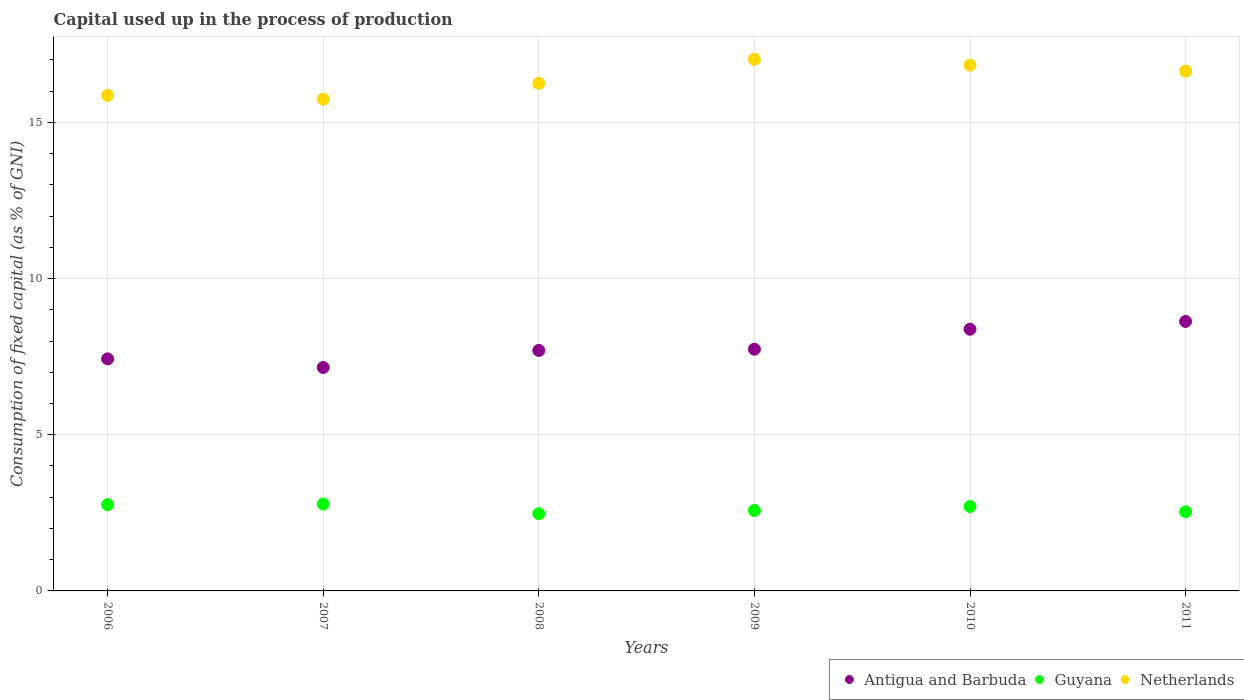What is the capital used up in the process of production in Netherlands in 2007?
Your answer should be compact. 15.75. Across all years, what is the maximum capital used up in the process of production in Netherlands?
Give a very brief answer. 17.02. Across all years, what is the minimum capital used up in the process of production in Guyana?
Your response must be concise. 2.47. What is the total capital used up in the process of production in Antigua and Barbuda in the graph?
Make the answer very short. 47.03. What is the difference between the capital used up in the process of production in Antigua and Barbuda in 2009 and that in 2010?
Provide a short and direct response. -0.64. What is the difference between the capital used up in the process of production in Antigua and Barbuda in 2006 and the capital used up in the process of production in Netherlands in 2007?
Make the answer very short. -8.32. What is the average capital used up in the process of production in Guyana per year?
Provide a short and direct response. 2.64. In the year 2007, what is the difference between the capital used up in the process of production in Netherlands and capital used up in the process of production in Guyana?
Ensure brevity in your answer.  12.96. In how many years, is the capital used up in the process of production in Guyana greater than 12 %?
Your response must be concise. 0. What is the ratio of the capital used up in the process of production in Guyana in 2009 to that in 2011?
Ensure brevity in your answer.  1.02. What is the difference between the highest and the second highest capital used up in the process of production in Antigua and Barbuda?
Keep it short and to the point. 0.25. What is the difference between the highest and the lowest capital used up in the process of production in Guyana?
Provide a short and direct response. 0.31. In how many years, is the capital used up in the process of production in Netherlands greater than the average capital used up in the process of production in Netherlands taken over all years?
Give a very brief answer. 3. Is the sum of the capital used up in the process of production in Netherlands in 2006 and 2010 greater than the maximum capital used up in the process of production in Guyana across all years?
Offer a very short reply. Yes. Is it the case that in every year, the sum of the capital used up in the process of production in Netherlands and capital used up in the process of production in Antigua and Barbuda  is greater than the capital used up in the process of production in Guyana?
Provide a short and direct response. Yes. Is the capital used up in the process of production in Guyana strictly less than the capital used up in the process of production in Antigua and Barbuda over the years?
Offer a very short reply. Yes. What is the difference between two consecutive major ticks on the Y-axis?
Give a very brief answer. 5. Are the values on the major ticks of Y-axis written in scientific E-notation?
Your response must be concise. No. Does the graph contain any zero values?
Your answer should be very brief. No. How many legend labels are there?
Provide a short and direct response. 3. How are the legend labels stacked?
Ensure brevity in your answer.  Horizontal. What is the title of the graph?
Your answer should be very brief. Capital used up in the process of production. Does "Nigeria" appear as one of the legend labels in the graph?
Offer a very short reply. No. What is the label or title of the Y-axis?
Give a very brief answer. Consumption of fixed capital (as % of GNI). What is the Consumption of fixed capital (as % of GNI) in Antigua and Barbuda in 2006?
Your answer should be compact. 7.43. What is the Consumption of fixed capital (as % of GNI) of Guyana in 2006?
Your response must be concise. 2.76. What is the Consumption of fixed capital (as % of GNI) of Netherlands in 2006?
Your response must be concise. 15.87. What is the Consumption of fixed capital (as % of GNI) in Antigua and Barbuda in 2007?
Provide a succinct answer. 7.15. What is the Consumption of fixed capital (as % of GNI) in Guyana in 2007?
Keep it short and to the point. 2.78. What is the Consumption of fixed capital (as % of GNI) in Netherlands in 2007?
Your answer should be compact. 15.75. What is the Consumption of fixed capital (as % of GNI) in Antigua and Barbuda in 2008?
Offer a very short reply. 7.7. What is the Consumption of fixed capital (as % of GNI) of Guyana in 2008?
Your response must be concise. 2.47. What is the Consumption of fixed capital (as % of GNI) of Netherlands in 2008?
Your answer should be very brief. 16.25. What is the Consumption of fixed capital (as % of GNI) in Antigua and Barbuda in 2009?
Give a very brief answer. 7.74. What is the Consumption of fixed capital (as % of GNI) of Guyana in 2009?
Offer a very short reply. 2.58. What is the Consumption of fixed capital (as % of GNI) in Netherlands in 2009?
Your answer should be compact. 17.02. What is the Consumption of fixed capital (as % of GNI) in Antigua and Barbuda in 2010?
Make the answer very short. 8.38. What is the Consumption of fixed capital (as % of GNI) of Guyana in 2010?
Offer a terse response. 2.7. What is the Consumption of fixed capital (as % of GNI) of Netherlands in 2010?
Keep it short and to the point. 16.83. What is the Consumption of fixed capital (as % of GNI) in Antigua and Barbuda in 2011?
Make the answer very short. 8.63. What is the Consumption of fixed capital (as % of GNI) in Guyana in 2011?
Keep it short and to the point. 2.53. What is the Consumption of fixed capital (as % of GNI) in Netherlands in 2011?
Offer a very short reply. 16.64. Across all years, what is the maximum Consumption of fixed capital (as % of GNI) of Antigua and Barbuda?
Ensure brevity in your answer.  8.63. Across all years, what is the maximum Consumption of fixed capital (as % of GNI) in Guyana?
Keep it short and to the point. 2.78. Across all years, what is the maximum Consumption of fixed capital (as % of GNI) in Netherlands?
Keep it short and to the point. 17.02. Across all years, what is the minimum Consumption of fixed capital (as % of GNI) in Antigua and Barbuda?
Make the answer very short. 7.15. Across all years, what is the minimum Consumption of fixed capital (as % of GNI) in Guyana?
Offer a very short reply. 2.47. Across all years, what is the minimum Consumption of fixed capital (as % of GNI) of Netherlands?
Your response must be concise. 15.75. What is the total Consumption of fixed capital (as % of GNI) of Antigua and Barbuda in the graph?
Your answer should be very brief. 47.03. What is the total Consumption of fixed capital (as % of GNI) of Guyana in the graph?
Your answer should be very brief. 15.83. What is the total Consumption of fixed capital (as % of GNI) in Netherlands in the graph?
Provide a succinct answer. 98.36. What is the difference between the Consumption of fixed capital (as % of GNI) of Antigua and Barbuda in 2006 and that in 2007?
Offer a terse response. 0.28. What is the difference between the Consumption of fixed capital (as % of GNI) of Guyana in 2006 and that in 2007?
Your answer should be compact. -0.02. What is the difference between the Consumption of fixed capital (as % of GNI) of Netherlands in 2006 and that in 2007?
Offer a terse response. 0.12. What is the difference between the Consumption of fixed capital (as % of GNI) in Antigua and Barbuda in 2006 and that in 2008?
Ensure brevity in your answer.  -0.27. What is the difference between the Consumption of fixed capital (as % of GNI) in Guyana in 2006 and that in 2008?
Your response must be concise. 0.29. What is the difference between the Consumption of fixed capital (as % of GNI) in Netherlands in 2006 and that in 2008?
Give a very brief answer. -0.39. What is the difference between the Consumption of fixed capital (as % of GNI) in Antigua and Barbuda in 2006 and that in 2009?
Offer a very short reply. -0.31. What is the difference between the Consumption of fixed capital (as % of GNI) of Guyana in 2006 and that in 2009?
Provide a short and direct response. 0.19. What is the difference between the Consumption of fixed capital (as % of GNI) in Netherlands in 2006 and that in 2009?
Your answer should be very brief. -1.15. What is the difference between the Consumption of fixed capital (as % of GNI) in Antigua and Barbuda in 2006 and that in 2010?
Provide a succinct answer. -0.95. What is the difference between the Consumption of fixed capital (as % of GNI) of Guyana in 2006 and that in 2010?
Provide a succinct answer. 0.06. What is the difference between the Consumption of fixed capital (as % of GNI) of Netherlands in 2006 and that in 2010?
Your response must be concise. -0.97. What is the difference between the Consumption of fixed capital (as % of GNI) of Antigua and Barbuda in 2006 and that in 2011?
Your answer should be compact. -1.2. What is the difference between the Consumption of fixed capital (as % of GNI) in Guyana in 2006 and that in 2011?
Your response must be concise. 0.23. What is the difference between the Consumption of fixed capital (as % of GNI) of Netherlands in 2006 and that in 2011?
Your answer should be compact. -0.78. What is the difference between the Consumption of fixed capital (as % of GNI) in Antigua and Barbuda in 2007 and that in 2008?
Your response must be concise. -0.55. What is the difference between the Consumption of fixed capital (as % of GNI) in Guyana in 2007 and that in 2008?
Your answer should be compact. 0.31. What is the difference between the Consumption of fixed capital (as % of GNI) of Netherlands in 2007 and that in 2008?
Your answer should be very brief. -0.51. What is the difference between the Consumption of fixed capital (as % of GNI) of Antigua and Barbuda in 2007 and that in 2009?
Provide a short and direct response. -0.58. What is the difference between the Consumption of fixed capital (as % of GNI) of Guyana in 2007 and that in 2009?
Keep it short and to the point. 0.21. What is the difference between the Consumption of fixed capital (as % of GNI) of Netherlands in 2007 and that in 2009?
Your response must be concise. -1.28. What is the difference between the Consumption of fixed capital (as % of GNI) of Antigua and Barbuda in 2007 and that in 2010?
Offer a terse response. -1.22. What is the difference between the Consumption of fixed capital (as % of GNI) in Guyana in 2007 and that in 2010?
Make the answer very short. 0.08. What is the difference between the Consumption of fixed capital (as % of GNI) of Netherlands in 2007 and that in 2010?
Your answer should be very brief. -1.09. What is the difference between the Consumption of fixed capital (as % of GNI) in Antigua and Barbuda in 2007 and that in 2011?
Your answer should be very brief. -1.47. What is the difference between the Consumption of fixed capital (as % of GNI) in Guyana in 2007 and that in 2011?
Offer a terse response. 0.25. What is the difference between the Consumption of fixed capital (as % of GNI) of Netherlands in 2007 and that in 2011?
Keep it short and to the point. -0.9. What is the difference between the Consumption of fixed capital (as % of GNI) of Antigua and Barbuda in 2008 and that in 2009?
Provide a short and direct response. -0.04. What is the difference between the Consumption of fixed capital (as % of GNI) in Guyana in 2008 and that in 2009?
Give a very brief answer. -0.1. What is the difference between the Consumption of fixed capital (as % of GNI) of Netherlands in 2008 and that in 2009?
Your answer should be very brief. -0.77. What is the difference between the Consumption of fixed capital (as % of GNI) of Antigua and Barbuda in 2008 and that in 2010?
Offer a very short reply. -0.68. What is the difference between the Consumption of fixed capital (as % of GNI) of Guyana in 2008 and that in 2010?
Keep it short and to the point. -0.23. What is the difference between the Consumption of fixed capital (as % of GNI) of Netherlands in 2008 and that in 2010?
Provide a succinct answer. -0.58. What is the difference between the Consumption of fixed capital (as % of GNI) of Antigua and Barbuda in 2008 and that in 2011?
Make the answer very short. -0.93. What is the difference between the Consumption of fixed capital (as % of GNI) in Guyana in 2008 and that in 2011?
Make the answer very short. -0.06. What is the difference between the Consumption of fixed capital (as % of GNI) of Netherlands in 2008 and that in 2011?
Keep it short and to the point. -0.39. What is the difference between the Consumption of fixed capital (as % of GNI) in Antigua and Barbuda in 2009 and that in 2010?
Give a very brief answer. -0.64. What is the difference between the Consumption of fixed capital (as % of GNI) in Guyana in 2009 and that in 2010?
Offer a terse response. -0.13. What is the difference between the Consumption of fixed capital (as % of GNI) in Netherlands in 2009 and that in 2010?
Provide a short and direct response. 0.19. What is the difference between the Consumption of fixed capital (as % of GNI) of Antigua and Barbuda in 2009 and that in 2011?
Your answer should be very brief. -0.89. What is the difference between the Consumption of fixed capital (as % of GNI) of Guyana in 2009 and that in 2011?
Make the answer very short. 0.04. What is the difference between the Consumption of fixed capital (as % of GNI) in Netherlands in 2009 and that in 2011?
Offer a terse response. 0.38. What is the difference between the Consumption of fixed capital (as % of GNI) in Antigua and Barbuda in 2010 and that in 2011?
Give a very brief answer. -0.25. What is the difference between the Consumption of fixed capital (as % of GNI) of Guyana in 2010 and that in 2011?
Make the answer very short. 0.17. What is the difference between the Consumption of fixed capital (as % of GNI) of Netherlands in 2010 and that in 2011?
Offer a terse response. 0.19. What is the difference between the Consumption of fixed capital (as % of GNI) of Antigua and Barbuda in 2006 and the Consumption of fixed capital (as % of GNI) of Guyana in 2007?
Your answer should be very brief. 4.65. What is the difference between the Consumption of fixed capital (as % of GNI) in Antigua and Barbuda in 2006 and the Consumption of fixed capital (as % of GNI) in Netherlands in 2007?
Provide a short and direct response. -8.32. What is the difference between the Consumption of fixed capital (as % of GNI) in Guyana in 2006 and the Consumption of fixed capital (as % of GNI) in Netherlands in 2007?
Provide a short and direct response. -12.98. What is the difference between the Consumption of fixed capital (as % of GNI) in Antigua and Barbuda in 2006 and the Consumption of fixed capital (as % of GNI) in Guyana in 2008?
Your answer should be very brief. 4.96. What is the difference between the Consumption of fixed capital (as % of GNI) of Antigua and Barbuda in 2006 and the Consumption of fixed capital (as % of GNI) of Netherlands in 2008?
Offer a very short reply. -8.82. What is the difference between the Consumption of fixed capital (as % of GNI) of Guyana in 2006 and the Consumption of fixed capital (as % of GNI) of Netherlands in 2008?
Give a very brief answer. -13.49. What is the difference between the Consumption of fixed capital (as % of GNI) of Antigua and Barbuda in 2006 and the Consumption of fixed capital (as % of GNI) of Guyana in 2009?
Keep it short and to the point. 4.85. What is the difference between the Consumption of fixed capital (as % of GNI) in Antigua and Barbuda in 2006 and the Consumption of fixed capital (as % of GNI) in Netherlands in 2009?
Ensure brevity in your answer.  -9.59. What is the difference between the Consumption of fixed capital (as % of GNI) in Guyana in 2006 and the Consumption of fixed capital (as % of GNI) in Netherlands in 2009?
Keep it short and to the point. -14.26. What is the difference between the Consumption of fixed capital (as % of GNI) in Antigua and Barbuda in 2006 and the Consumption of fixed capital (as % of GNI) in Guyana in 2010?
Make the answer very short. 4.73. What is the difference between the Consumption of fixed capital (as % of GNI) in Antigua and Barbuda in 2006 and the Consumption of fixed capital (as % of GNI) in Netherlands in 2010?
Provide a short and direct response. -9.4. What is the difference between the Consumption of fixed capital (as % of GNI) of Guyana in 2006 and the Consumption of fixed capital (as % of GNI) of Netherlands in 2010?
Make the answer very short. -14.07. What is the difference between the Consumption of fixed capital (as % of GNI) of Antigua and Barbuda in 2006 and the Consumption of fixed capital (as % of GNI) of Guyana in 2011?
Offer a terse response. 4.9. What is the difference between the Consumption of fixed capital (as % of GNI) in Antigua and Barbuda in 2006 and the Consumption of fixed capital (as % of GNI) in Netherlands in 2011?
Offer a very short reply. -9.21. What is the difference between the Consumption of fixed capital (as % of GNI) of Guyana in 2006 and the Consumption of fixed capital (as % of GNI) of Netherlands in 2011?
Your response must be concise. -13.88. What is the difference between the Consumption of fixed capital (as % of GNI) of Antigua and Barbuda in 2007 and the Consumption of fixed capital (as % of GNI) of Guyana in 2008?
Your answer should be compact. 4.68. What is the difference between the Consumption of fixed capital (as % of GNI) of Antigua and Barbuda in 2007 and the Consumption of fixed capital (as % of GNI) of Netherlands in 2008?
Make the answer very short. -9.1. What is the difference between the Consumption of fixed capital (as % of GNI) in Guyana in 2007 and the Consumption of fixed capital (as % of GNI) in Netherlands in 2008?
Your answer should be very brief. -13.47. What is the difference between the Consumption of fixed capital (as % of GNI) in Antigua and Barbuda in 2007 and the Consumption of fixed capital (as % of GNI) in Guyana in 2009?
Ensure brevity in your answer.  4.58. What is the difference between the Consumption of fixed capital (as % of GNI) in Antigua and Barbuda in 2007 and the Consumption of fixed capital (as % of GNI) in Netherlands in 2009?
Offer a terse response. -9.87. What is the difference between the Consumption of fixed capital (as % of GNI) in Guyana in 2007 and the Consumption of fixed capital (as % of GNI) in Netherlands in 2009?
Your answer should be compact. -14.24. What is the difference between the Consumption of fixed capital (as % of GNI) in Antigua and Barbuda in 2007 and the Consumption of fixed capital (as % of GNI) in Guyana in 2010?
Ensure brevity in your answer.  4.45. What is the difference between the Consumption of fixed capital (as % of GNI) in Antigua and Barbuda in 2007 and the Consumption of fixed capital (as % of GNI) in Netherlands in 2010?
Provide a succinct answer. -9.68. What is the difference between the Consumption of fixed capital (as % of GNI) of Guyana in 2007 and the Consumption of fixed capital (as % of GNI) of Netherlands in 2010?
Make the answer very short. -14.05. What is the difference between the Consumption of fixed capital (as % of GNI) of Antigua and Barbuda in 2007 and the Consumption of fixed capital (as % of GNI) of Guyana in 2011?
Ensure brevity in your answer.  4.62. What is the difference between the Consumption of fixed capital (as % of GNI) of Antigua and Barbuda in 2007 and the Consumption of fixed capital (as % of GNI) of Netherlands in 2011?
Keep it short and to the point. -9.49. What is the difference between the Consumption of fixed capital (as % of GNI) of Guyana in 2007 and the Consumption of fixed capital (as % of GNI) of Netherlands in 2011?
Provide a short and direct response. -13.86. What is the difference between the Consumption of fixed capital (as % of GNI) in Antigua and Barbuda in 2008 and the Consumption of fixed capital (as % of GNI) in Guyana in 2009?
Your answer should be very brief. 5.12. What is the difference between the Consumption of fixed capital (as % of GNI) of Antigua and Barbuda in 2008 and the Consumption of fixed capital (as % of GNI) of Netherlands in 2009?
Provide a short and direct response. -9.32. What is the difference between the Consumption of fixed capital (as % of GNI) in Guyana in 2008 and the Consumption of fixed capital (as % of GNI) in Netherlands in 2009?
Offer a terse response. -14.55. What is the difference between the Consumption of fixed capital (as % of GNI) of Antigua and Barbuda in 2008 and the Consumption of fixed capital (as % of GNI) of Guyana in 2010?
Your answer should be very brief. 5. What is the difference between the Consumption of fixed capital (as % of GNI) in Antigua and Barbuda in 2008 and the Consumption of fixed capital (as % of GNI) in Netherlands in 2010?
Offer a very short reply. -9.13. What is the difference between the Consumption of fixed capital (as % of GNI) of Guyana in 2008 and the Consumption of fixed capital (as % of GNI) of Netherlands in 2010?
Keep it short and to the point. -14.36. What is the difference between the Consumption of fixed capital (as % of GNI) of Antigua and Barbuda in 2008 and the Consumption of fixed capital (as % of GNI) of Guyana in 2011?
Provide a short and direct response. 5.17. What is the difference between the Consumption of fixed capital (as % of GNI) of Antigua and Barbuda in 2008 and the Consumption of fixed capital (as % of GNI) of Netherlands in 2011?
Provide a short and direct response. -8.94. What is the difference between the Consumption of fixed capital (as % of GNI) in Guyana in 2008 and the Consumption of fixed capital (as % of GNI) in Netherlands in 2011?
Provide a short and direct response. -14.17. What is the difference between the Consumption of fixed capital (as % of GNI) in Antigua and Barbuda in 2009 and the Consumption of fixed capital (as % of GNI) in Guyana in 2010?
Offer a very short reply. 5.04. What is the difference between the Consumption of fixed capital (as % of GNI) in Antigua and Barbuda in 2009 and the Consumption of fixed capital (as % of GNI) in Netherlands in 2010?
Your response must be concise. -9.1. What is the difference between the Consumption of fixed capital (as % of GNI) in Guyana in 2009 and the Consumption of fixed capital (as % of GNI) in Netherlands in 2010?
Provide a succinct answer. -14.26. What is the difference between the Consumption of fixed capital (as % of GNI) of Antigua and Barbuda in 2009 and the Consumption of fixed capital (as % of GNI) of Guyana in 2011?
Your answer should be compact. 5.21. What is the difference between the Consumption of fixed capital (as % of GNI) in Antigua and Barbuda in 2009 and the Consumption of fixed capital (as % of GNI) in Netherlands in 2011?
Provide a short and direct response. -8.9. What is the difference between the Consumption of fixed capital (as % of GNI) in Guyana in 2009 and the Consumption of fixed capital (as % of GNI) in Netherlands in 2011?
Ensure brevity in your answer.  -14.07. What is the difference between the Consumption of fixed capital (as % of GNI) of Antigua and Barbuda in 2010 and the Consumption of fixed capital (as % of GNI) of Guyana in 2011?
Provide a succinct answer. 5.84. What is the difference between the Consumption of fixed capital (as % of GNI) of Antigua and Barbuda in 2010 and the Consumption of fixed capital (as % of GNI) of Netherlands in 2011?
Your answer should be very brief. -8.26. What is the difference between the Consumption of fixed capital (as % of GNI) of Guyana in 2010 and the Consumption of fixed capital (as % of GNI) of Netherlands in 2011?
Your answer should be very brief. -13.94. What is the average Consumption of fixed capital (as % of GNI) of Antigua and Barbuda per year?
Ensure brevity in your answer.  7.84. What is the average Consumption of fixed capital (as % of GNI) in Guyana per year?
Ensure brevity in your answer.  2.64. What is the average Consumption of fixed capital (as % of GNI) of Netherlands per year?
Offer a terse response. 16.39. In the year 2006, what is the difference between the Consumption of fixed capital (as % of GNI) in Antigua and Barbuda and Consumption of fixed capital (as % of GNI) in Guyana?
Keep it short and to the point. 4.67. In the year 2006, what is the difference between the Consumption of fixed capital (as % of GNI) in Antigua and Barbuda and Consumption of fixed capital (as % of GNI) in Netherlands?
Make the answer very short. -8.44. In the year 2006, what is the difference between the Consumption of fixed capital (as % of GNI) of Guyana and Consumption of fixed capital (as % of GNI) of Netherlands?
Your answer should be compact. -13.11. In the year 2007, what is the difference between the Consumption of fixed capital (as % of GNI) in Antigua and Barbuda and Consumption of fixed capital (as % of GNI) in Guyana?
Your answer should be compact. 4.37. In the year 2007, what is the difference between the Consumption of fixed capital (as % of GNI) of Antigua and Barbuda and Consumption of fixed capital (as % of GNI) of Netherlands?
Your answer should be very brief. -8.59. In the year 2007, what is the difference between the Consumption of fixed capital (as % of GNI) of Guyana and Consumption of fixed capital (as % of GNI) of Netherlands?
Give a very brief answer. -12.96. In the year 2008, what is the difference between the Consumption of fixed capital (as % of GNI) of Antigua and Barbuda and Consumption of fixed capital (as % of GNI) of Guyana?
Offer a terse response. 5.23. In the year 2008, what is the difference between the Consumption of fixed capital (as % of GNI) of Antigua and Barbuda and Consumption of fixed capital (as % of GNI) of Netherlands?
Offer a very short reply. -8.55. In the year 2008, what is the difference between the Consumption of fixed capital (as % of GNI) in Guyana and Consumption of fixed capital (as % of GNI) in Netherlands?
Make the answer very short. -13.78. In the year 2009, what is the difference between the Consumption of fixed capital (as % of GNI) of Antigua and Barbuda and Consumption of fixed capital (as % of GNI) of Guyana?
Your response must be concise. 5.16. In the year 2009, what is the difference between the Consumption of fixed capital (as % of GNI) of Antigua and Barbuda and Consumption of fixed capital (as % of GNI) of Netherlands?
Give a very brief answer. -9.28. In the year 2009, what is the difference between the Consumption of fixed capital (as % of GNI) in Guyana and Consumption of fixed capital (as % of GNI) in Netherlands?
Your answer should be very brief. -14.45. In the year 2010, what is the difference between the Consumption of fixed capital (as % of GNI) in Antigua and Barbuda and Consumption of fixed capital (as % of GNI) in Guyana?
Offer a terse response. 5.68. In the year 2010, what is the difference between the Consumption of fixed capital (as % of GNI) in Antigua and Barbuda and Consumption of fixed capital (as % of GNI) in Netherlands?
Your answer should be compact. -8.46. In the year 2010, what is the difference between the Consumption of fixed capital (as % of GNI) in Guyana and Consumption of fixed capital (as % of GNI) in Netherlands?
Your answer should be very brief. -14.13. In the year 2011, what is the difference between the Consumption of fixed capital (as % of GNI) in Antigua and Barbuda and Consumption of fixed capital (as % of GNI) in Guyana?
Keep it short and to the point. 6.09. In the year 2011, what is the difference between the Consumption of fixed capital (as % of GNI) in Antigua and Barbuda and Consumption of fixed capital (as % of GNI) in Netherlands?
Your answer should be very brief. -8.01. In the year 2011, what is the difference between the Consumption of fixed capital (as % of GNI) of Guyana and Consumption of fixed capital (as % of GNI) of Netherlands?
Provide a succinct answer. -14.11. What is the ratio of the Consumption of fixed capital (as % of GNI) in Antigua and Barbuda in 2006 to that in 2007?
Your answer should be very brief. 1.04. What is the ratio of the Consumption of fixed capital (as % of GNI) of Netherlands in 2006 to that in 2007?
Your answer should be compact. 1.01. What is the ratio of the Consumption of fixed capital (as % of GNI) in Guyana in 2006 to that in 2008?
Your response must be concise. 1.12. What is the ratio of the Consumption of fixed capital (as % of GNI) in Netherlands in 2006 to that in 2008?
Ensure brevity in your answer.  0.98. What is the ratio of the Consumption of fixed capital (as % of GNI) in Antigua and Barbuda in 2006 to that in 2009?
Ensure brevity in your answer.  0.96. What is the ratio of the Consumption of fixed capital (as % of GNI) of Guyana in 2006 to that in 2009?
Provide a short and direct response. 1.07. What is the ratio of the Consumption of fixed capital (as % of GNI) of Netherlands in 2006 to that in 2009?
Your answer should be compact. 0.93. What is the ratio of the Consumption of fixed capital (as % of GNI) of Antigua and Barbuda in 2006 to that in 2010?
Provide a short and direct response. 0.89. What is the ratio of the Consumption of fixed capital (as % of GNI) of Guyana in 2006 to that in 2010?
Your answer should be very brief. 1.02. What is the ratio of the Consumption of fixed capital (as % of GNI) of Netherlands in 2006 to that in 2010?
Your response must be concise. 0.94. What is the ratio of the Consumption of fixed capital (as % of GNI) of Antigua and Barbuda in 2006 to that in 2011?
Ensure brevity in your answer.  0.86. What is the ratio of the Consumption of fixed capital (as % of GNI) in Guyana in 2006 to that in 2011?
Your answer should be compact. 1.09. What is the ratio of the Consumption of fixed capital (as % of GNI) in Netherlands in 2006 to that in 2011?
Provide a succinct answer. 0.95. What is the ratio of the Consumption of fixed capital (as % of GNI) in Antigua and Barbuda in 2007 to that in 2008?
Give a very brief answer. 0.93. What is the ratio of the Consumption of fixed capital (as % of GNI) in Guyana in 2007 to that in 2008?
Offer a very short reply. 1.13. What is the ratio of the Consumption of fixed capital (as % of GNI) in Netherlands in 2007 to that in 2008?
Your answer should be very brief. 0.97. What is the ratio of the Consumption of fixed capital (as % of GNI) in Antigua and Barbuda in 2007 to that in 2009?
Keep it short and to the point. 0.92. What is the ratio of the Consumption of fixed capital (as % of GNI) of Guyana in 2007 to that in 2009?
Keep it short and to the point. 1.08. What is the ratio of the Consumption of fixed capital (as % of GNI) of Netherlands in 2007 to that in 2009?
Your answer should be very brief. 0.93. What is the ratio of the Consumption of fixed capital (as % of GNI) in Antigua and Barbuda in 2007 to that in 2010?
Keep it short and to the point. 0.85. What is the ratio of the Consumption of fixed capital (as % of GNI) of Guyana in 2007 to that in 2010?
Provide a succinct answer. 1.03. What is the ratio of the Consumption of fixed capital (as % of GNI) in Netherlands in 2007 to that in 2010?
Provide a short and direct response. 0.94. What is the ratio of the Consumption of fixed capital (as % of GNI) of Antigua and Barbuda in 2007 to that in 2011?
Your answer should be very brief. 0.83. What is the ratio of the Consumption of fixed capital (as % of GNI) of Guyana in 2007 to that in 2011?
Offer a terse response. 1.1. What is the ratio of the Consumption of fixed capital (as % of GNI) of Netherlands in 2007 to that in 2011?
Offer a terse response. 0.95. What is the ratio of the Consumption of fixed capital (as % of GNI) of Antigua and Barbuda in 2008 to that in 2009?
Ensure brevity in your answer.  0.99. What is the ratio of the Consumption of fixed capital (as % of GNI) of Netherlands in 2008 to that in 2009?
Your response must be concise. 0.95. What is the ratio of the Consumption of fixed capital (as % of GNI) in Antigua and Barbuda in 2008 to that in 2010?
Ensure brevity in your answer.  0.92. What is the ratio of the Consumption of fixed capital (as % of GNI) of Guyana in 2008 to that in 2010?
Give a very brief answer. 0.91. What is the ratio of the Consumption of fixed capital (as % of GNI) of Netherlands in 2008 to that in 2010?
Provide a short and direct response. 0.97. What is the ratio of the Consumption of fixed capital (as % of GNI) in Antigua and Barbuda in 2008 to that in 2011?
Your answer should be very brief. 0.89. What is the ratio of the Consumption of fixed capital (as % of GNI) of Guyana in 2008 to that in 2011?
Provide a short and direct response. 0.98. What is the ratio of the Consumption of fixed capital (as % of GNI) of Netherlands in 2008 to that in 2011?
Make the answer very short. 0.98. What is the ratio of the Consumption of fixed capital (as % of GNI) of Antigua and Barbuda in 2009 to that in 2010?
Keep it short and to the point. 0.92. What is the ratio of the Consumption of fixed capital (as % of GNI) in Guyana in 2009 to that in 2010?
Offer a very short reply. 0.95. What is the ratio of the Consumption of fixed capital (as % of GNI) of Netherlands in 2009 to that in 2010?
Offer a terse response. 1.01. What is the ratio of the Consumption of fixed capital (as % of GNI) in Antigua and Barbuda in 2009 to that in 2011?
Keep it short and to the point. 0.9. What is the ratio of the Consumption of fixed capital (as % of GNI) of Guyana in 2009 to that in 2011?
Make the answer very short. 1.02. What is the ratio of the Consumption of fixed capital (as % of GNI) in Netherlands in 2009 to that in 2011?
Give a very brief answer. 1.02. What is the ratio of the Consumption of fixed capital (as % of GNI) in Antigua and Barbuda in 2010 to that in 2011?
Provide a short and direct response. 0.97. What is the ratio of the Consumption of fixed capital (as % of GNI) in Guyana in 2010 to that in 2011?
Offer a terse response. 1.07. What is the ratio of the Consumption of fixed capital (as % of GNI) of Netherlands in 2010 to that in 2011?
Your response must be concise. 1.01. What is the difference between the highest and the second highest Consumption of fixed capital (as % of GNI) of Antigua and Barbuda?
Offer a terse response. 0.25. What is the difference between the highest and the second highest Consumption of fixed capital (as % of GNI) in Guyana?
Your answer should be very brief. 0.02. What is the difference between the highest and the second highest Consumption of fixed capital (as % of GNI) in Netherlands?
Keep it short and to the point. 0.19. What is the difference between the highest and the lowest Consumption of fixed capital (as % of GNI) of Antigua and Barbuda?
Keep it short and to the point. 1.47. What is the difference between the highest and the lowest Consumption of fixed capital (as % of GNI) in Guyana?
Offer a terse response. 0.31. What is the difference between the highest and the lowest Consumption of fixed capital (as % of GNI) of Netherlands?
Provide a short and direct response. 1.28. 